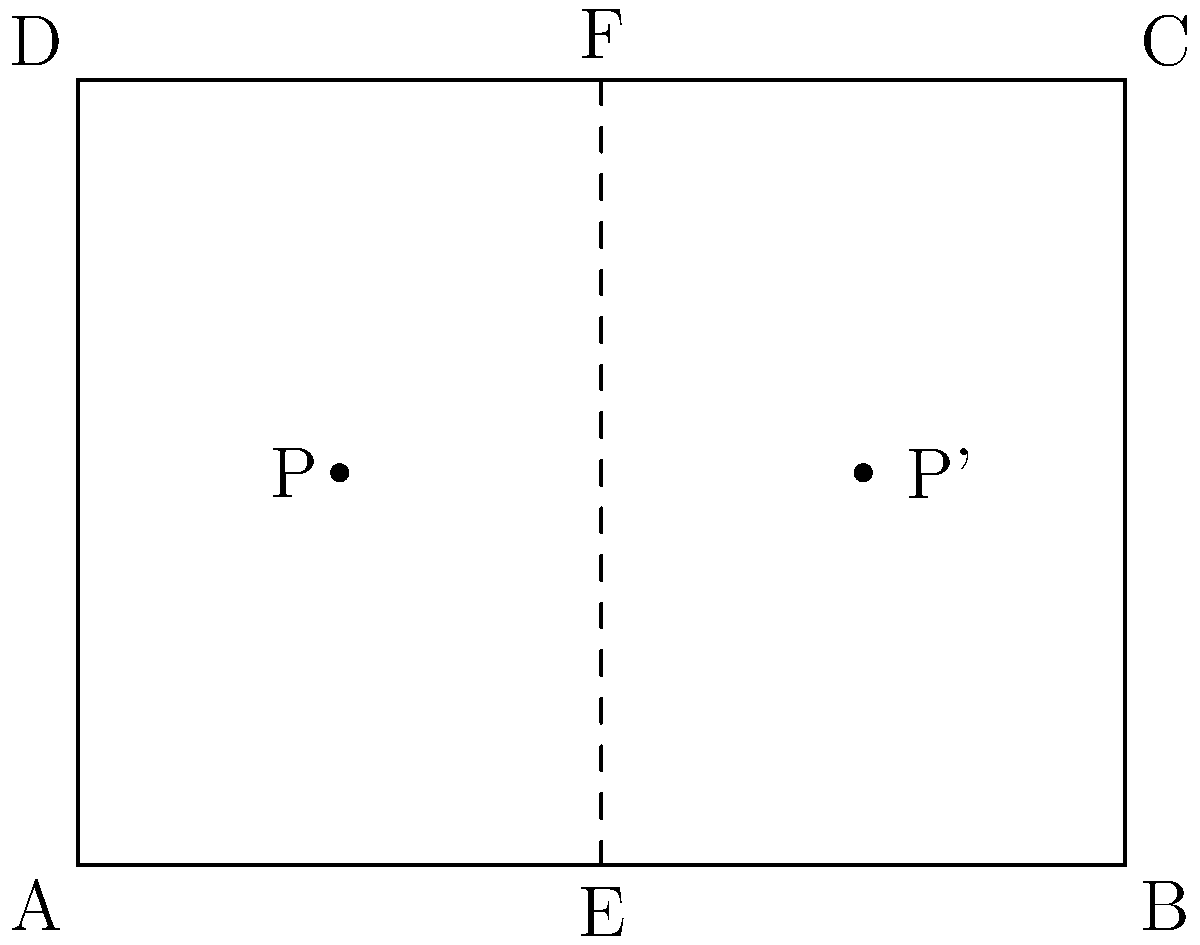A judo uniform design is represented by the rectangle ABCD. The dashed line EF represents the line of reflection symmetry. Point P is a design element on the left side of the uniform. If P is reflected across line EF to create P', what are the coordinates of P' given that P is located at (1, 1.5)? To find the coordinates of P' after reflecting P across the line EF, we can follow these steps:

1) First, note that the line of symmetry EF is vertical and passes through the middle of the rectangle at x = 2.

2) The x-coordinate of P is 1, which is 1 unit to the left of the line of symmetry.

3) When reflecting a point across a vertical line, the y-coordinate remains the same, and the x-coordinate changes by twice the distance from the point to the line of symmetry.

4) The distance from P to the line of symmetry is 2 - 1 = 1 unit.

5) Therefore, the x-coordinate of P' will be 1 unit to the right of the line of symmetry:
   $x_{P'} = 2 + 1 = 3$

6) The y-coordinate of P' will be the same as P:
   $y_{P'} = 1.5$

Thus, the coordinates of P' are (3, 1.5).
Answer: (3, 1.5) 